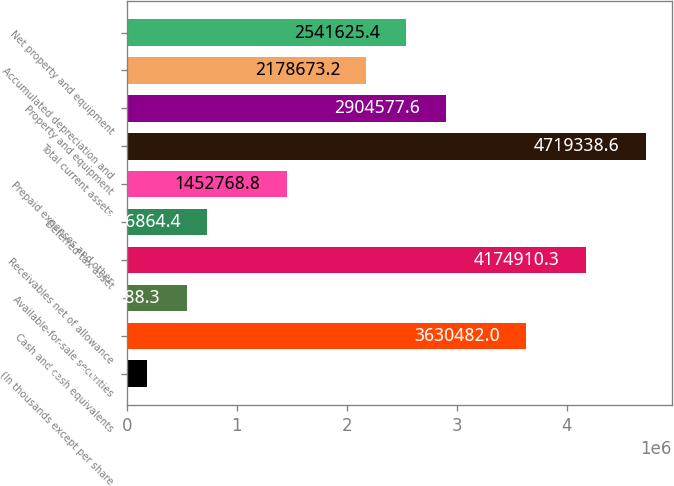Convert chart. <chart><loc_0><loc_0><loc_500><loc_500><bar_chart><fcel>(In thousands except per share<fcel>Cash and cash equivalents<fcel>Available-for-sale securities<fcel>Receivables net of allowance<fcel>Deferred tax asset<fcel>Prepaid expenses and other<fcel>Total current assets<fcel>Property and equipment<fcel>Accumulated depreciation and<fcel>Net property and equipment<nl><fcel>182436<fcel>3.63048e+06<fcel>545388<fcel>4.17491e+06<fcel>726864<fcel>1.45277e+06<fcel>4.71934e+06<fcel>2.90458e+06<fcel>2.17867e+06<fcel>2.54163e+06<nl></chart> 